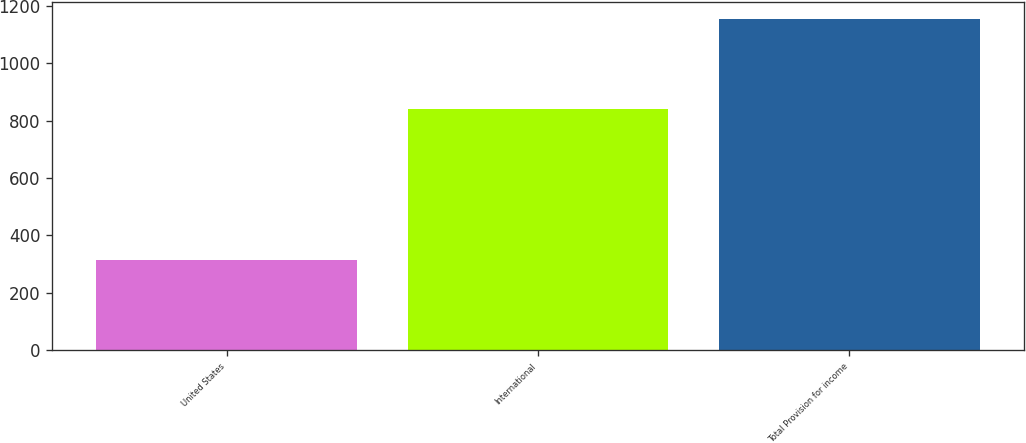Convert chart to OTSL. <chart><loc_0><loc_0><loc_500><loc_500><bar_chart><fcel>United States<fcel>International<fcel>Total Provision for income<nl><fcel>314<fcel>841<fcel>1155<nl></chart> 